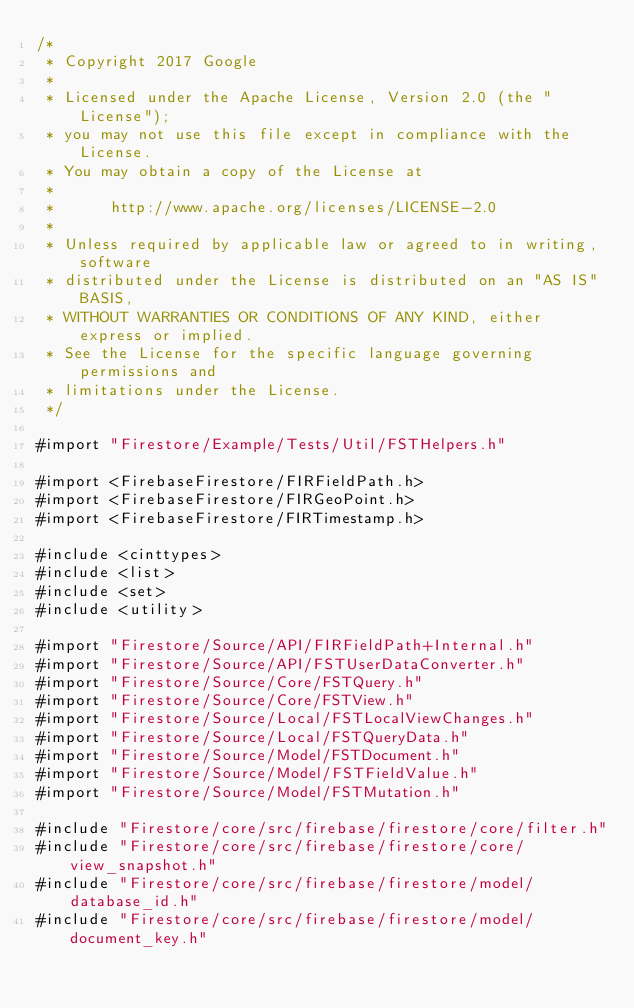Convert code to text. <code><loc_0><loc_0><loc_500><loc_500><_ObjectiveC_>/*
 * Copyright 2017 Google
 *
 * Licensed under the Apache License, Version 2.0 (the "License");
 * you may not use this file except in compliance with the License.
 * You may obtain a copy of the License at
 *
 *      http://www.apache.org/licenses/LICENSE-2.0
 *
 * Unless required by applicable law or agreed to in writing, software
 * distributed under the License is distributed on an "AS IS" BASIS,
 * WITHOUT WARRANTIES OR CONDITIONS OF ANY KIND, either express or implied.
 * See the License for the specific language governing permissions and
 * limitations under the License.
 */

#import "Firestore/Example/Tests/Util/FSTHelpers.h"

#import <FirebaseFirestore/FIRFieldPath.h>
#import <FirebaseFirestore/FIRGeoPoint.h>
#import <FirebaseFirestore/FIRTimestamp.h>

#include <cinttypes>
#include <list>
#include <set>
#include <utility>

#import "Firestore/Source/API/FIRFieldPath+Internal.h"
#import "Firestore/Source/API/FSTUserDataConverter.h"
#import "Firestore/Source/Core/FSTQuery.h"
#import "Firestore/Source/Core/FSTView.h"
#import "Firestore/Source/Local/FSTLocalViewChanges.h"
#import "Firestore/Source/Local/FSTQueryData.h"
#import "Firestore/Source/Model/FSTDocument.h"
#import "Firestore/Source/Model/FSTFieldValue.h"
#import "Firestore/Source/Model/FSTMutation.h"

#include "Firestore/core/src/firebase/firestore/core/filter.h"
#include "Firestore/core/src/firebase/firestore/core/view_snapshot.h"
#include "Firestore/core/src/firebase/firestore/model/database_id.h"
#include "Firestore/core/src/firebase/firestore/model/document_key.h"</code> 